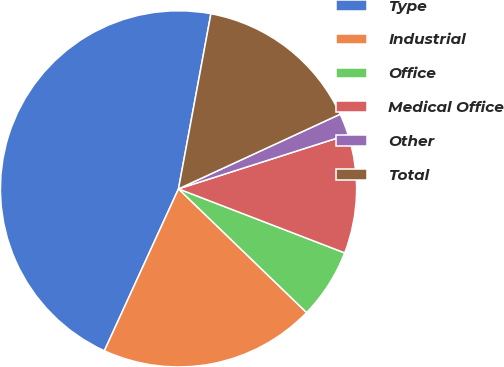Convert chart. <chart><loc_0><loc_0><loc_500><loc_500><pie_chart><fcel>Type<fcel>Industrial<fcel>Office<fcel>Medical Office<fcel>Other<fcel>Total<nl><fcel>46.08%<fcel>19.61%<fcel>6.37%<fcel>10.78%<fcel>1.96%<fcel>15.2%<nl></chart> 